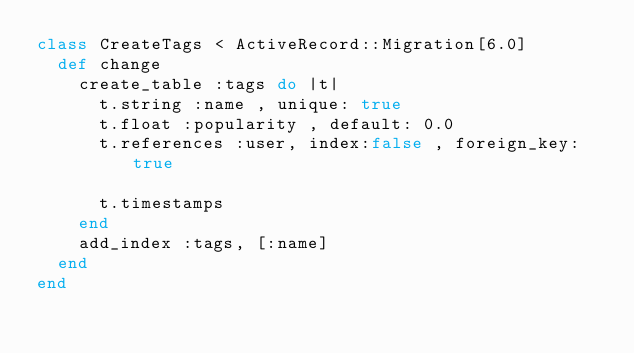Convert code to text. <code><loc_0><loc_0><loc_500><loc_500><_Ruby_>class CreateTags < ActiveRecord::Migration[6.0]
  def change
    create_table :tags do |t|
      t.string :name , unique: true
      t.float :popularity , default: 0.0
      t.references :user, index:false , foreign_key: true

      t.timestamps
    end
    add_index :tags, [:name]
  end
end
</code> 